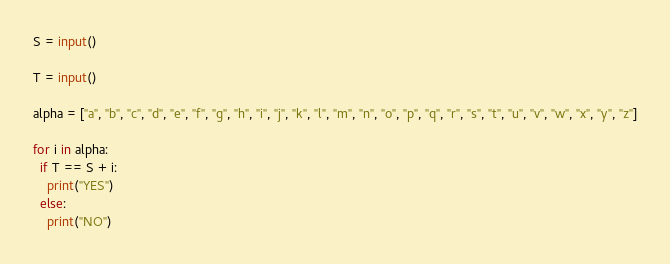Convert code to text. <code><loc_0><loc_0><loc_500><loc_500><_Python_>S = input()

T = input()

alpha = ["a", "b", "c", "d", "e", "f", "g", "h", "i", "j", "k", "l", "m", "n", "o", "p", "q", "r", "s", "t", "u", "v", "w", "x", "y", "z"]

for i in alpha:
  if T == S + i:
    print("YES")
  else:
    print("NO")</code> 